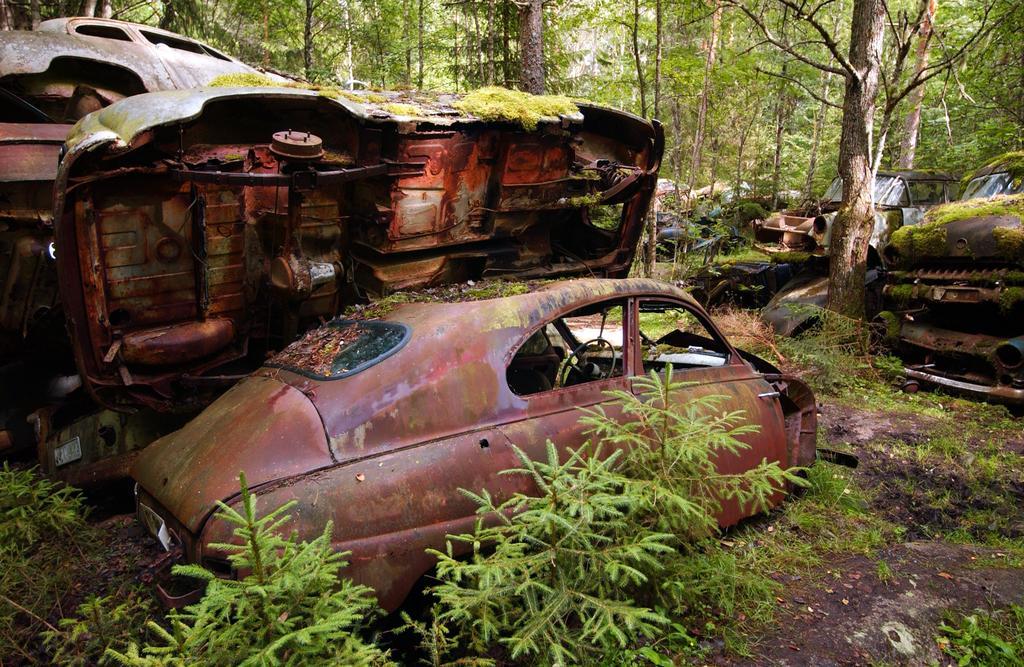Could you give a brief overview of what you see in this image? In this image there are some damaged cars as we can see in middle of this image. There are some plants at bottom of this image and there are some trees at top of this image. 